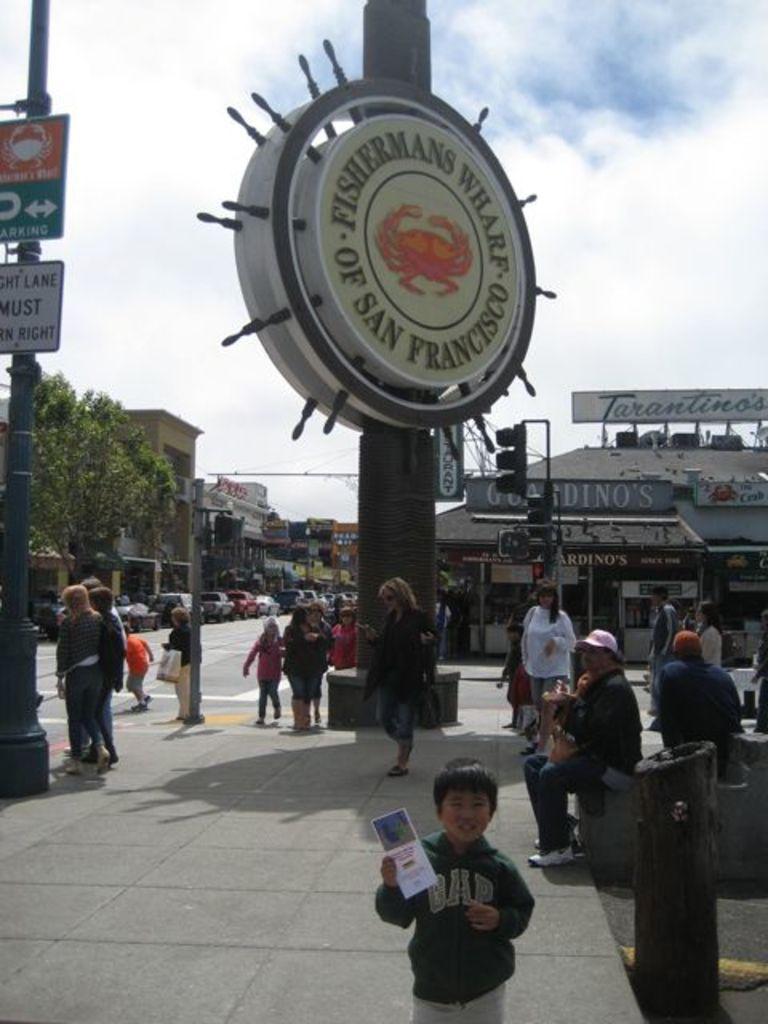Could you give a brief overview of what you see in this image? This looks like a name board, which is attached to a pole. I can see the traffic signals. There are few people walking and few people sitting. Here is a boy holding a paper in his hand and standing. I can see the buildings and a tree. These are the cars on the road. Here is the sky. I can see the name boards, which are on the roof. 